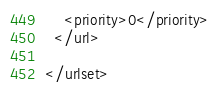<code> <loc_0><loc_0><loc_500><loc_500><_XML_>    <priority>0</priority>
  </url>
  
</urlset></code> 